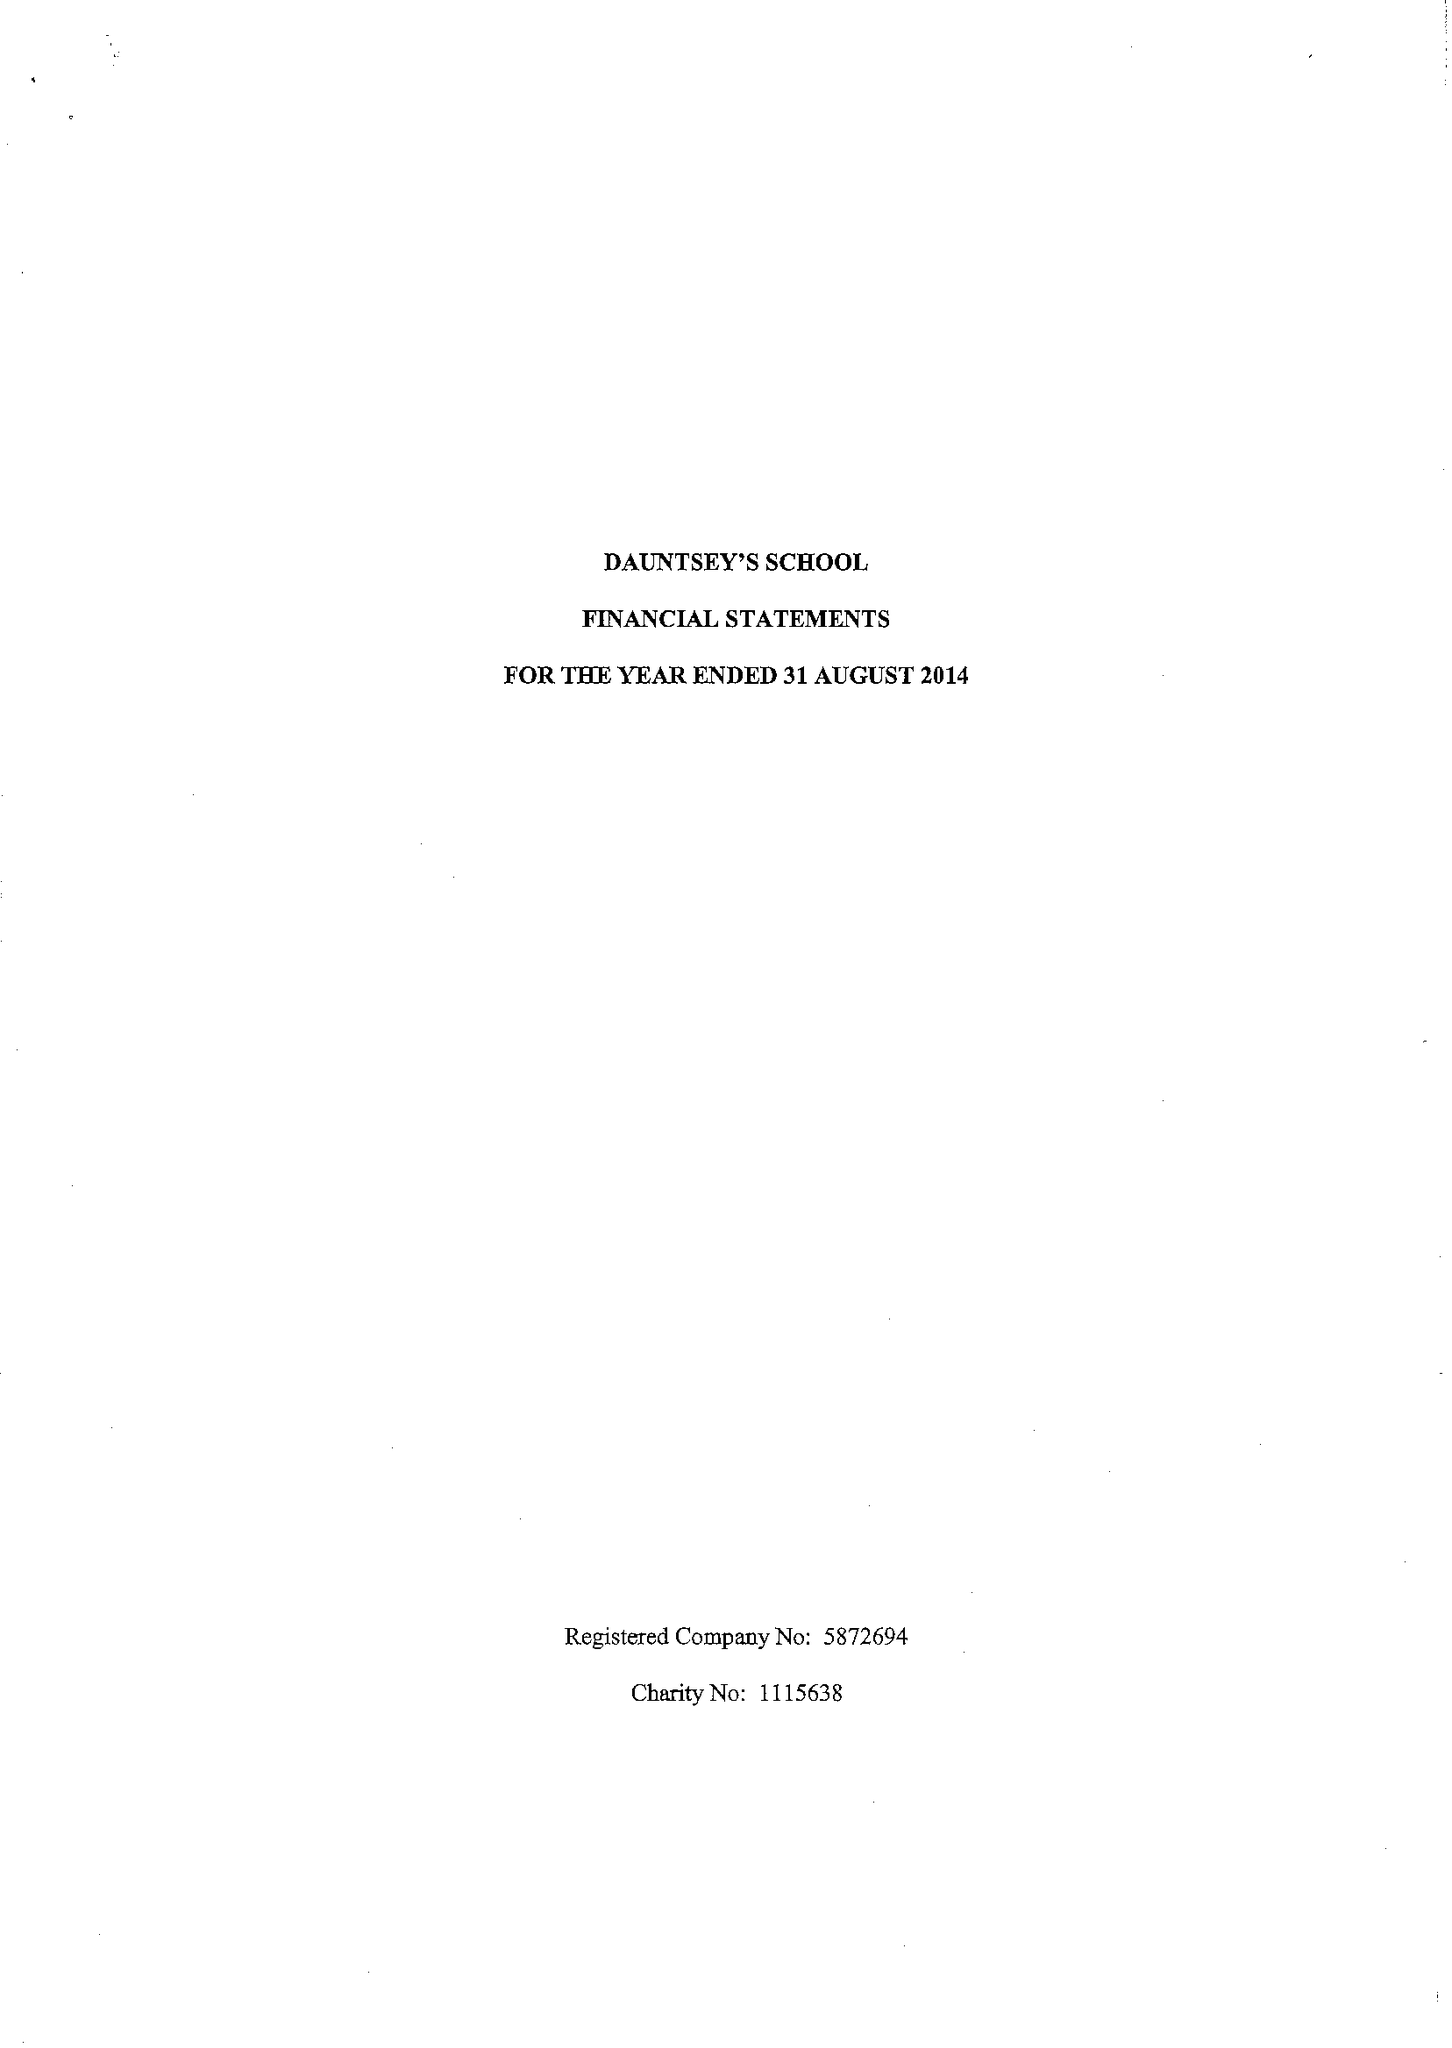What is the value for the address__postcode?
Answer the question using a single word or phrase. SN10 4HE 